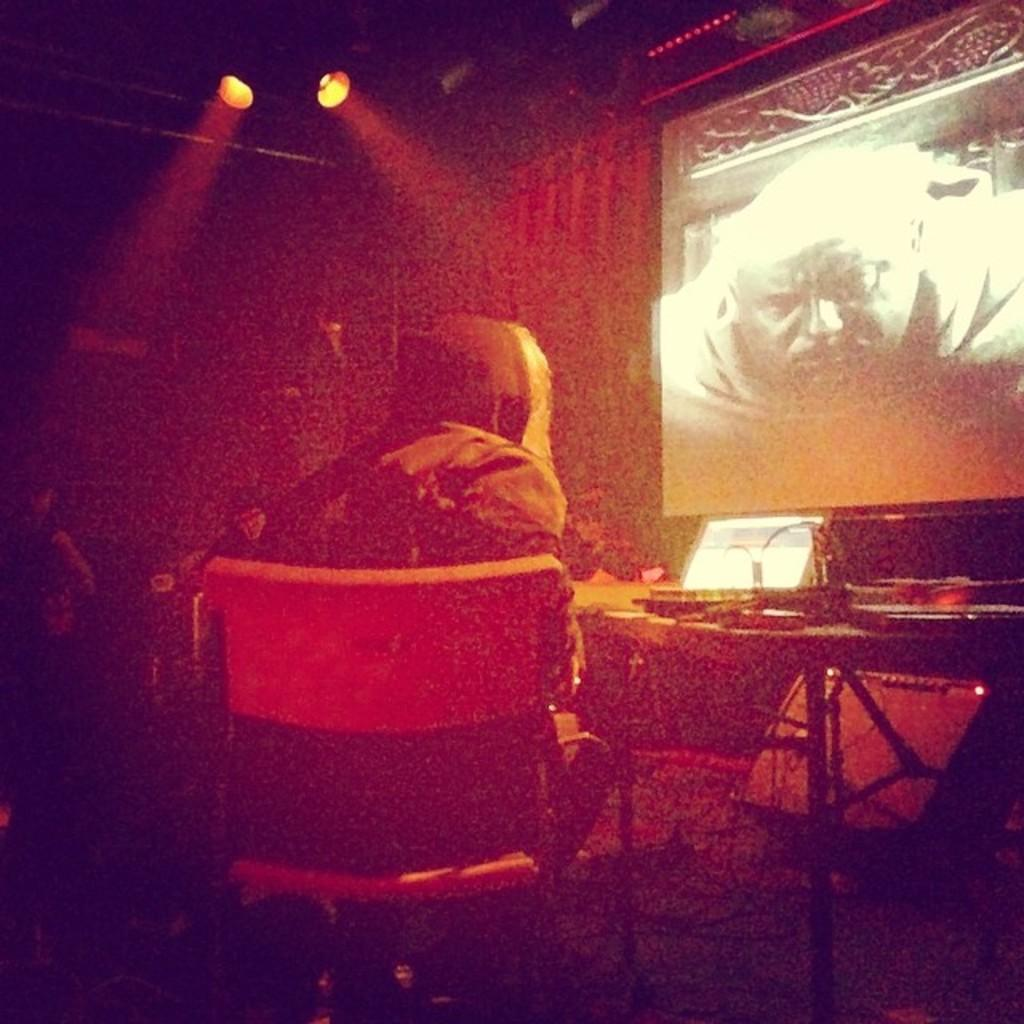What is the person in the image doing? The person is sitting on a chair. What is in front of the person? There is a table in front of the person. What can be seen on the table? There is a laptop on the table, along with other things. What is the purpose of the screen in the image? The screen is present for displaying information or visuals. What can be observed about the lighting in the image? There are focusing lights visible. How many bikes are parked near the person in the image? There are no bikes present in the image. Is the person solving a riddle on the laptop in the image? There is no indication in the image that the person is solving a riddle on the laptop. 